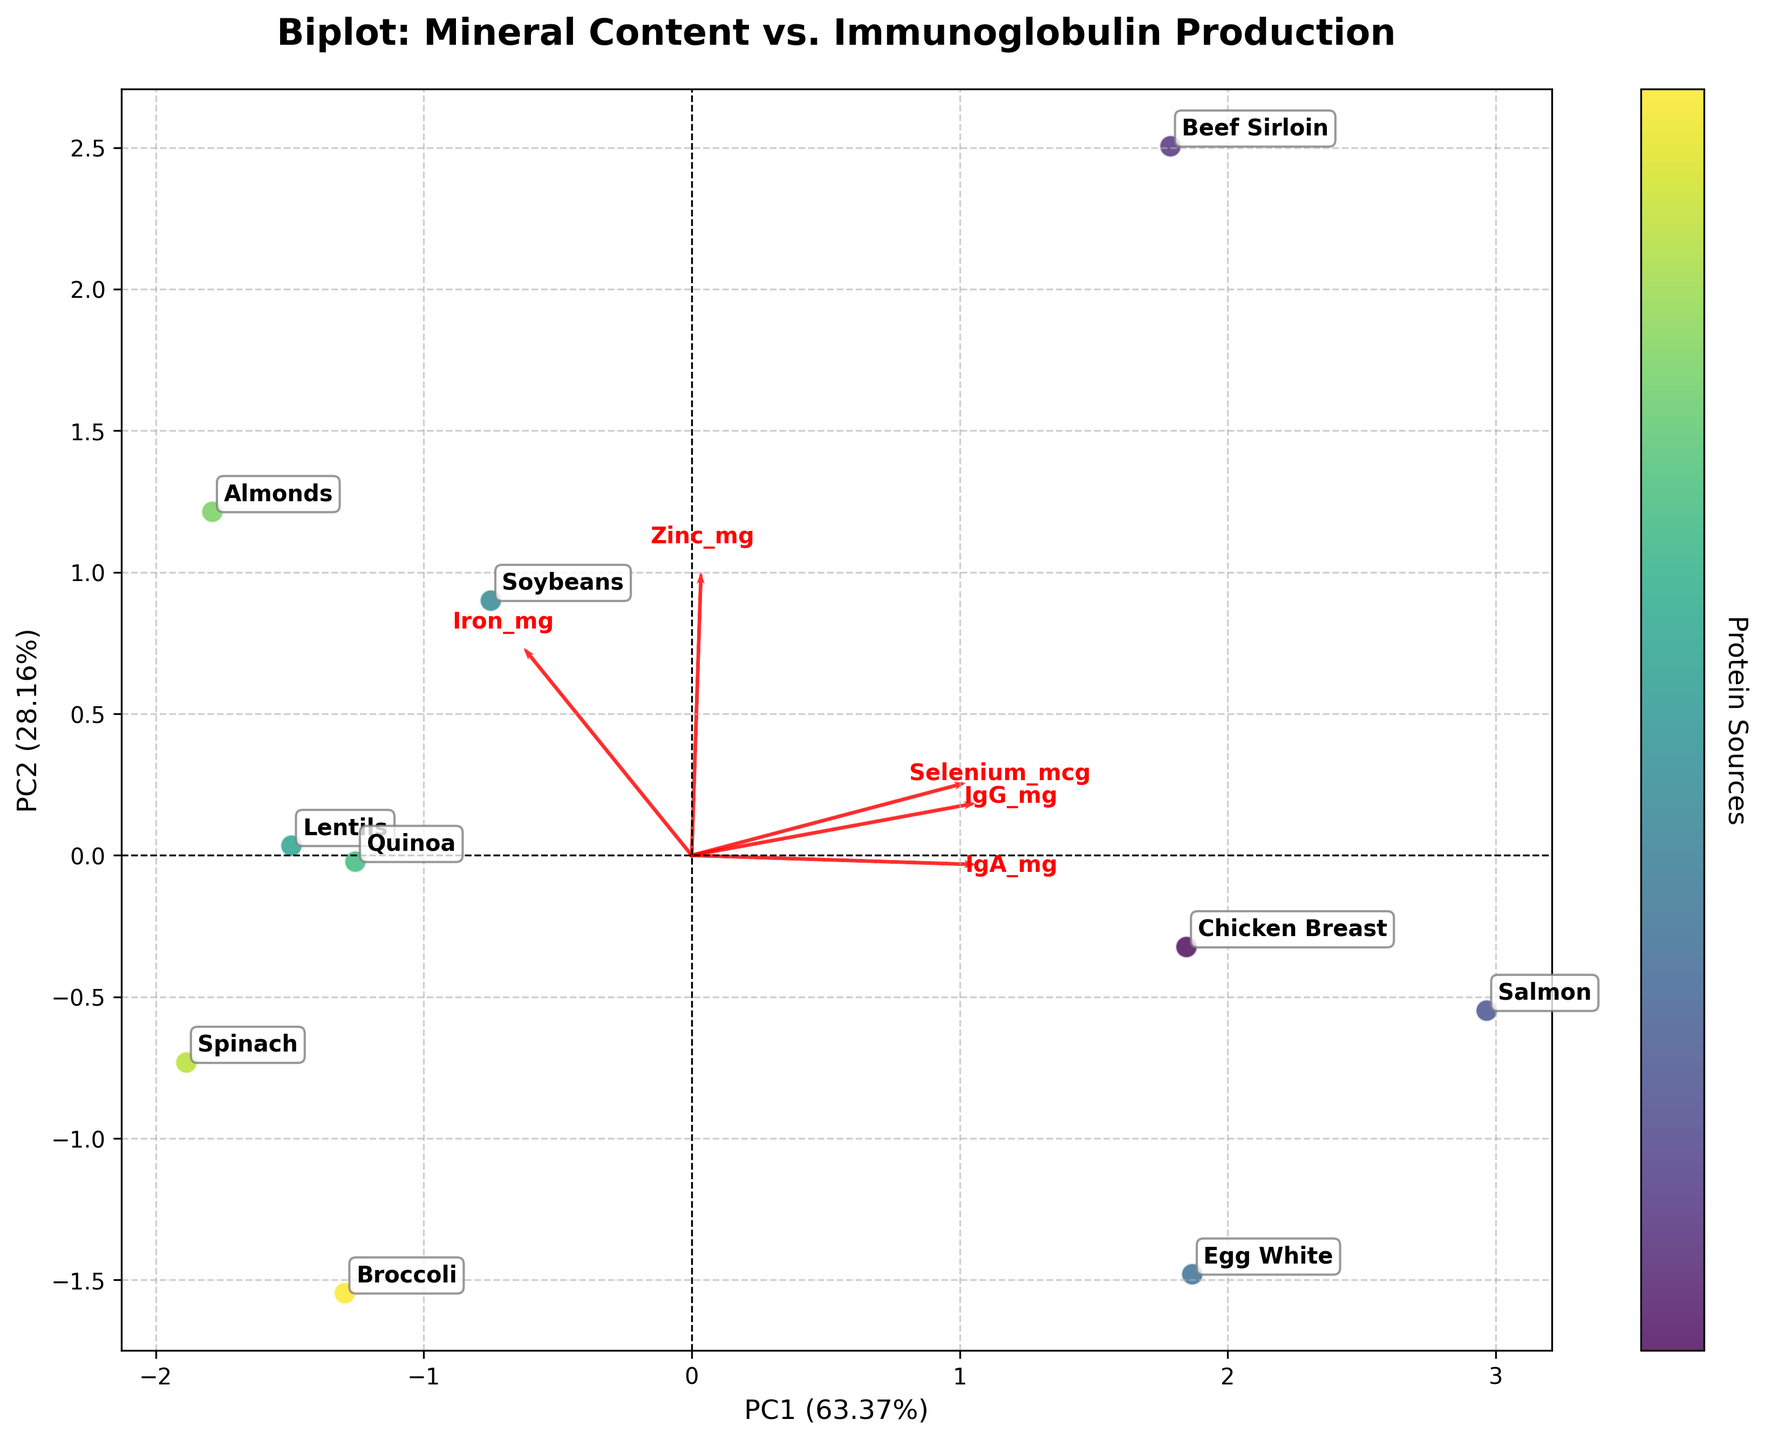What is the title of the biplot? The title is typically displayed at the top of the plot. In this case, it is "Biplot: Mineral Content vs. Immunoglobulin Production".
Answer: Biplot: Mineral Content vs. Immunoglobulin Production What are the axes labels on the biplot? The axes labels can be found along the horizontal and vertical axes. Here, the x-axis is labeled "PC1" with the explained variance, and the y-axis is labeled "PC2" with the explained variance.
Answer: PC1 and PC2 Which protein source is closest to "Iron"? By looking at the position of the arrows and the points on the plot, we can see that "Iron" is represented by one of the red arrows. The protein source closest to this arrow is "Soybeans".
Answer: Soybeans How does Chicken Breast compare to Beef Sirloin in terms of their PC1 and PC2 scores? Locate "Chicken Breast" and "Beef Sirloin" on the plot. "Chicken Breast" is towards the left (lower values of PC1) and slightly lower on PC2, while "Beef Sirloin" is further right (higher values of PC1) and slightly higher on PC2.
Answer: Chicken Breast has lower PC1 and slightly lower PC2 scores than Beef Sirloin Which mineral has the smallest loading on PC2? Examine the red arrows representing minerals. The arrow with the smallest displacement in the vertical direction (PC2) corresponds to "Zinc".
Answer: Zinc How many protein sources are represented in total? Count the number of distinct labels annotated on the plot. There are 10 protein sources represented in total.
Answer: 10 Which nutrient appears to have the most significant influence on PC1? The nutrient with the arrow pointing farthest in the horizontal direction (PC1) has the most influence. This is represented by "Iron".
Answer: Iron Which protein source has the highest IgG concentration based on the biplot? Look for the annotation or labeling nearest the arrow representing IgG. "Salmon" is close to the "IgG" arrow, indicating it has the highest concentration.
Answer: Salmon What is the approximate explained variance for PC1 and PC2? The explained variance for the principal components is usually noted on the axes labels. PC1 explains around 42.86%, and PC2 explains about 31.43%.
Answer: 42.86% for PC1 and 31.43% for PC2 Between Soybeans and Lentils, which is closer to the center of the biplot origin (0,0)? Find the positions of "Soybeans" and "Lentils". "Lentils" is closer to the center of the plot (0,0) compared to "Soybeans".
Answer: Lentils 